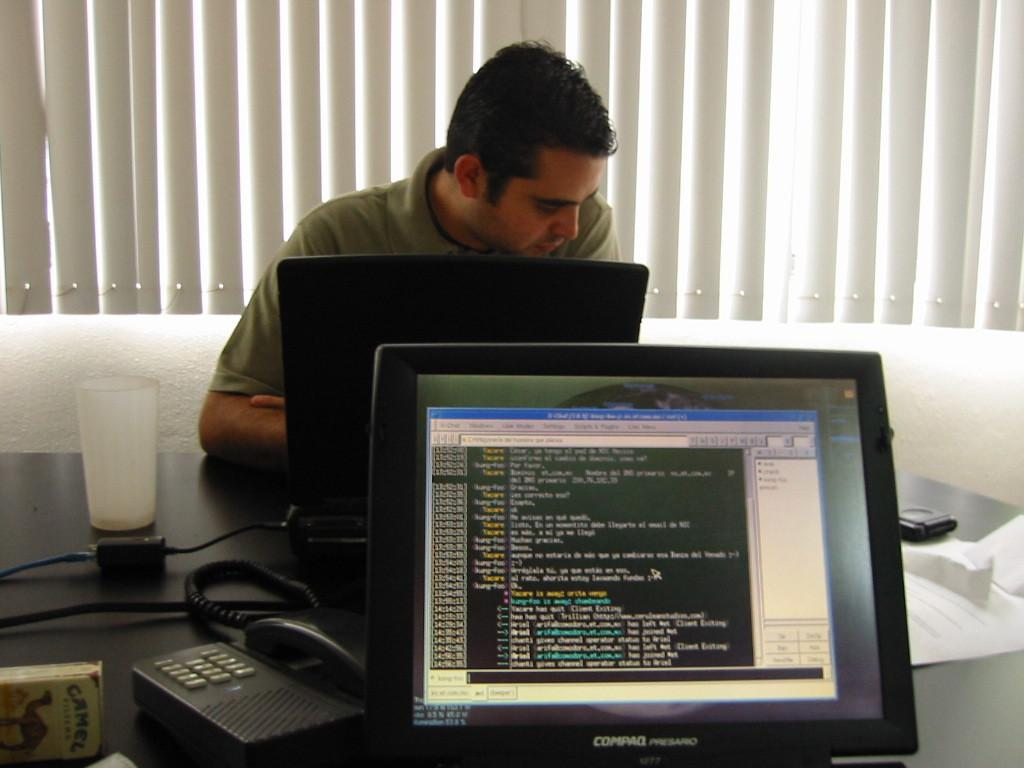<image>
Share a concise interpretation of the image provided. The computer screen shown is made by Compaq. 